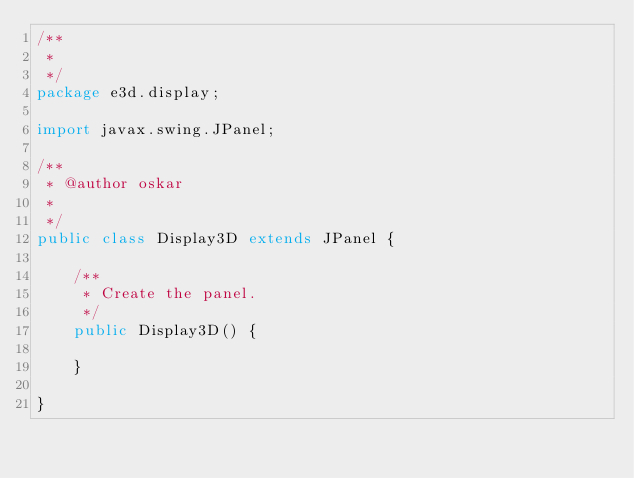<code> <loc_0><loc_0><loc_500><loc_500><_Java_>/**
 * 
 */
package e3d.display;

import javax.swing.JPanel;

/**
 * @author oskar
 *
 */
public class Display3D extends JPanel {

	/**
	 * Create the panel.
	 */
	public Display3D() {

	}

}
</code> 